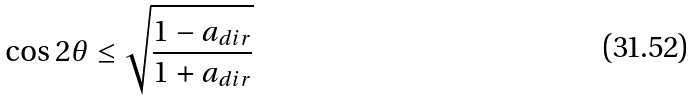Convert formula to latex. <formula><loc_0><loc_0><loc_500><loc_500>\cos 2 \theta \leq \sqrt { \frac { 1 - a _ { d i r } } { 1 + a _ { d i r } } }</formula> 